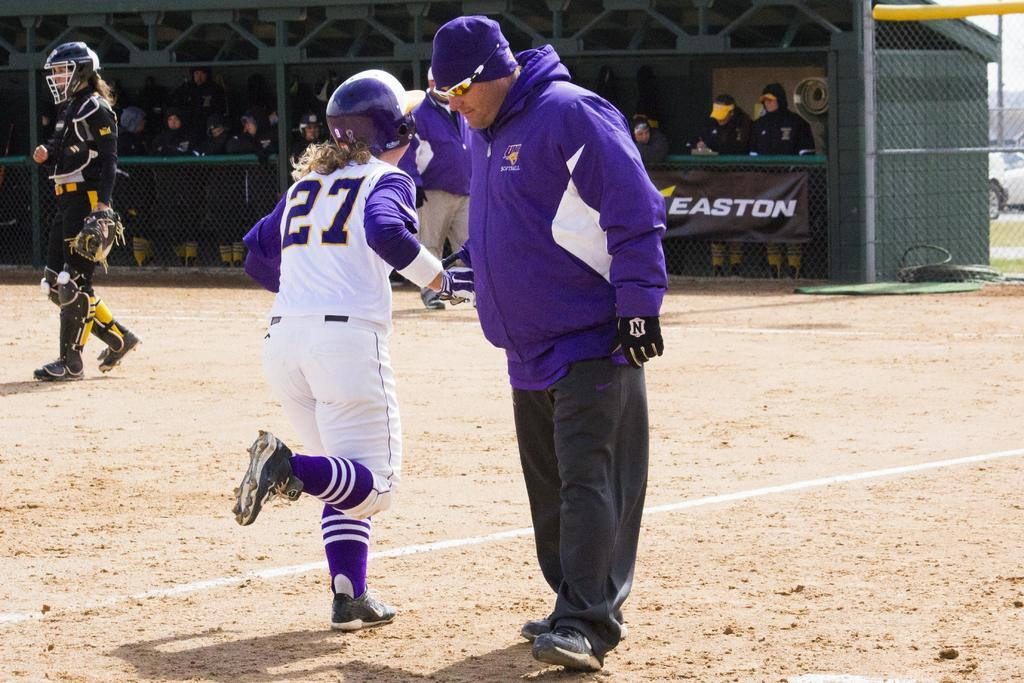Provide a one-sentence caption for the provided image. A baseball player running past their coach with Easton in the background. 